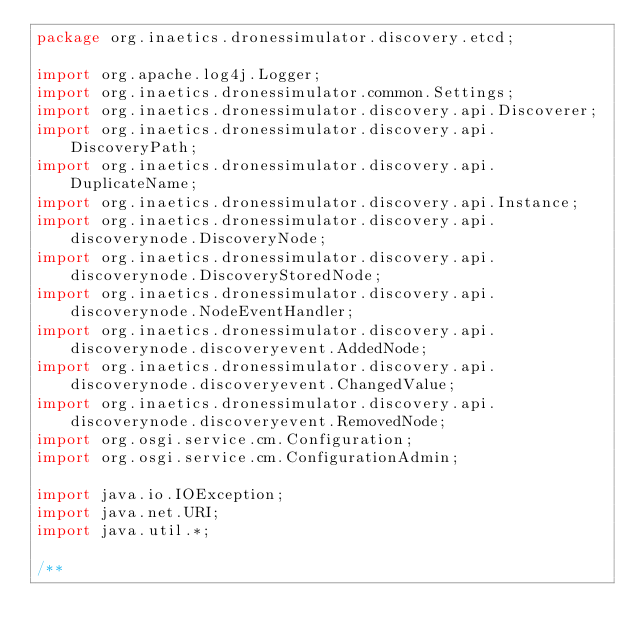<code> <loc_0><loc_0><loc_500><loc_500><_Java_>package org.inaetics.dronessimulator.discovery.etcd;

import org.apache.log4j.Logger;
import org.inaetics.dronessimulator.common.Settings;
import org.inaetics.dronessimulator.discovery.api.Discoverer;
import org.inaetics.dronessimulator.discovery.api.DiscoveryPath;
import org.inaetics.dronessimulator.discovery.api.DuplicateName;
import org.inaetics.dronessimulator.discovery.api.Instance;
import org.inaetics.dronessimulator.discovery.api.discoverynode.DiscoveryNode;
import org.inaetics.dronessimulator.discovery.api.discoverynode.DiscoveryStoredNode;
import org.inaetics.dronessimulator.discovery.api.discoverynode.NodeEventHandler;
import org.inaetics.dronessimulator.discovery.api.discoverynode.discoveryevent.AddedNode;
import org.inaetics.dronessimulator.discovery.api.discoverynode.discoveryevent.ChangedValue;
import org.inaetics.dronessimulator.discovery.api.discoverynode.discoveryevent.RemovedNode;
import org.osgi.service.cm.Configuration;
import org.osgi.service.cm.ConfigurationAdmin;

import java.io.IOException;
import java.net.URI;
import java.util.*;

/**</code> 